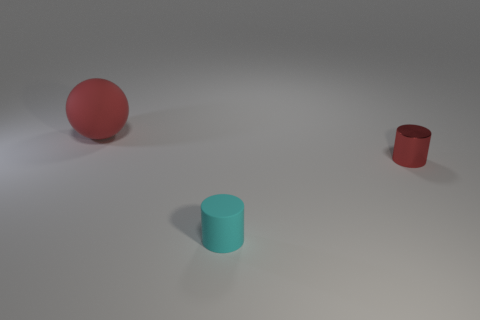What number of cylinders are the same color as the large ball?
Your answer should be compact. 1. What is the red object that is right of the big red thing made of?
Provide a succinct answer. Metal. Are there the same number of red spheres on the left side of the big red sphere and large gray shiny cylinders?
Offer a very short reply. Yes. Do the ball and the cyan rubber thing have the same size?
Your answer should be very brief. No. Is there a cylinder that is in front of the cylinder on the right side of the rubber thing that is in front of the tiny red metal cylinder?
Your answer should be very brief. Yes. There is a cyan thing that is the same shape as the tiny red object; what is its material?
Offer a terse response. Rubber. What number of red rubber objects are left of the large red matte thing that is to the left of the small metallic cylinder?
Ensure brevity in your answer.  0. There is a red object on the left side of the object right of the matte thing in front of the red sphere; what is its size?
Your answer should be very brief. Large. What color is the thing behind the red object on the right side of the cyan object?
Offer a very short reply. Red. What number of other things are the same material as the tiny cyan thing?
Offer a very short reply. 1. 